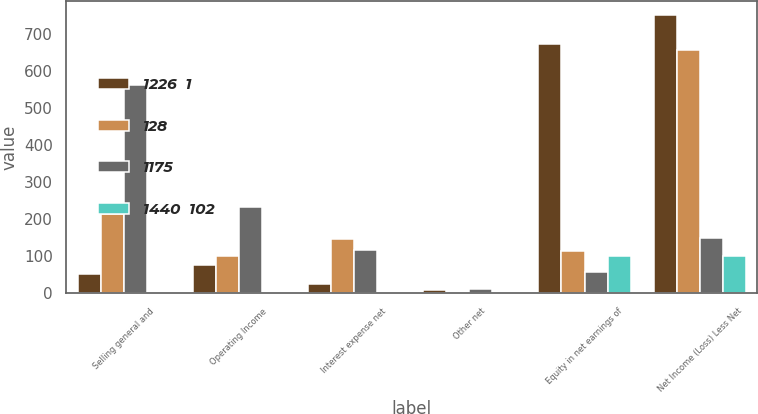Convert chart. <chart><loc_0><loc_0><loc_500><loc_500><stacked_bar_chart><ecel><fcel>Selling general and<fcel>Operating Income<fcel>Interest expense net<fcel>Other net<fcel>Equity in net earnings of<fcel>Net Income (Loss) Less Net<nl><fcel>1226  1<fcel>52<fcel>76<fcel>26<fcel>9<fcel>673<fcel>750<nl><fcel>128<fcel>215<fcel>102<fcel>148<fcel>0<fcel>115<fcel>655<nl><fcel>1175<fcel>561<fcel>234<fcel>117<fcel>12<fcel>59<fcel>150<nl><fcel>1440  102<fcel>1<fcel>0<fcel>0<fcel>0<fcel>102<fcel>102<nl></chart> 